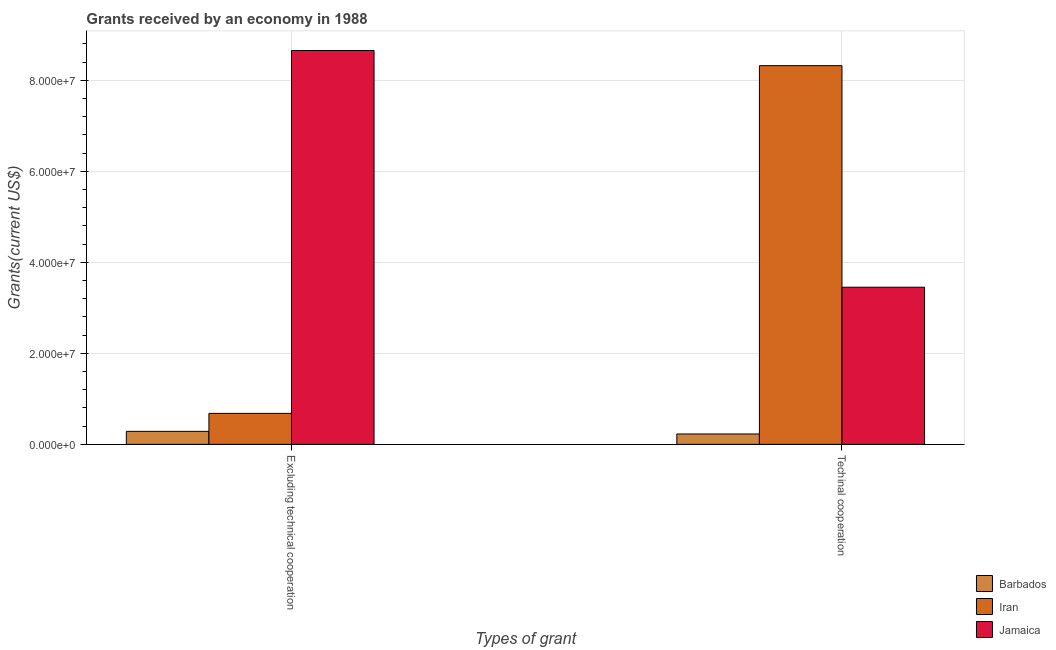How many groups of bars are there?
Give a very brief answer. 2. Are the number of bars per tick equal to the number of legend labels?
Your answer should be compact. Yes. Are the number of bars on each tick of the X-axis equal?
Your answer should be very brief. Yes. How many bars are there on the 2nd tick from the left?
Provide a succinct answer. 3. What is the label of the 1st group of bars from the left?
Ensure brevity in your answer.  Excluding technical cooperation. What is the amount of grants received(including technical cooperation) in Jamaica?
Provide a short and direct response. 3.45e+07. Across all countries, what is the maximum amount of grants received(including technical cooperation)?
Offer a terse response. 8.32e+07. Across all countries, what is the minimum amount of grants received(including technical cooperation)?
Offer a terse response. 2.28e+06. In which country was the amount of grants received(excluding technical cooperation) maximum?
Your answer should be compact. Jamaica. In which country was the amount of grants received(excluding technical cooperation) minimum?
Provide a succinct answer. Barbados. What is the total amount of grants received(excluding technical cooperation) in the graph?
Make the answer very short. 9.62e+07. What is the difference between the amount of grants received(excluding technical cooperation) in Iran and that in Barbados?
Provide a short and direct response. 3.95e+06. What is the difference between the amount of grants received(including technical cooperation) in Jamaica and the amount of grants received(excluding technical cooperation) in Iran?
Offer a very short reply. 2.77e+07. What is the average amount of grants received(excluding technical cooperation) per country?
Your answer should be very brief. 3.21e+07. What is the difference between the amount of grants received(excluding technical cooperation) and amount of grants received(including technical cooperation) in Jamaica?
Offer a terse response. 5.20e+07. In how many countries, is the amount of grants received(excluding technical cooperation) greater than 20000000 US$?
Your answer should be compact. 1. What is the ratio of the amount of grants received(including technical cooperation) in Jamaica to that in Iran?
Ensure brevity in your answer.  0.41. Is the amount of grants received(excluding technical cooperation) in Iran less than that in Barbados?
Your answer should be very brief. No. What does the 3rd bar from the left in Techinal cooperation represents?
Offer a terse response. Jamaica. What does the 1st bar from the right in Techinal cooperation represents?
Offer a very short reply. Jamaica. How many bars are there?
Offer a very short reply. 6. Are all the bars in the graph horizontal?
Your answer should be compact. No. Are the values on the major ticks of Y-axis written in scientific E-notation?
Ensure brevity in your answer.  Yes. How are the legend labels stacked?
Provide a succinct answer. Vertical. What is the title of the graph?
Offer a very short reply. Grants received by an economy in 1988. What is the label or title of the X-axis?
Keep it short and to the point. Types of grant. What is the label or title of the Y-axis?
Provide a short and direct response. Grants(current US$). What is the Grants(current US$) of Barbados in Excluding technical cooperation?
Provide a succinct answer. 2.86e+06. What is the Grants(current US$) in Iran in Excluding technical cooperation?
Your answer should be compact. 6.81e+06. What is the Grants(current US$) in Jamaica in Excluding technical cooperation?
Offer a very short reply. 8.66e+07. What is the Grants(current US$) in Barbados in Techinal cooperation?
Offer a very short reply. 2.28e+06. What is the Grants(current US$) of Iran in Techinal cooperation?
Ensure brevity in your answer.  8.32e+07. What is the Grants(current US$) of Jamaica in Techinal cooperation?
Provide a succinct answer. 3.45e+07. Across all Types of grant, what is the maximum Grants(current US$) in Barbados?
Your answer should be compact. 2.86e+06. Across all Types of grant, what is the maximum Grants(current US$) in Iran?
Give a very brief answer. 8.32e+07. Across all Types of grant, what is the maximum Grants(current US$) in Jamaica?
Your answer should be compact. 8.66e+07. Across all Types of grant, what is the minimum Grants(current US$) in Barbados?
Keep it short and to the point. 2.28e+06. Across all Types of grant, what is the minimum Grants(current US$) of Iran?
Your answer should be very brief. 6.81e+06. Across all Types of grant, what is the minimum Grants(current US$) in Jamaica?
Ensure brevity in your answer.  3.45e+07. What is the total Grants(current US$) of Barbados in the graph?
Offer a very short reply. 5.14e+06. What is the total Grants(current US$) of Iran in the graph?
Provide a short and direct response. 9.00e+07. What is the total Grants(current US$) of Jamaica in the graph?
Your answer should be very brief. 1.21e+08. What is the difference between the Grants(current US$) in Barbados in Excluding technical cooperation and that in Techinal cooperation?
Your response must be concise. 5.80e+05. What is the difference between the Grants(current US$) of Iran in Excluding technical cooperation and that in Techinal cooperation?
Keep it short and to the point. -7.64e+07. What is the difference between the Grants(current US$) of Jamaica in Excluding technical cooperation and that in Techinal cooperation?
Keep it short and to the point. 5.20e+07. What is the difference between the Grants(current US$) in Barbados in Excluding technical cooperation and the Grants(current US$) in Iran in Techinal cooperation?
Make the answer very short. -8.04e+07. What is the difference between the Grants(current US$) in Barbados in Excluding technical cooperation and the Grants(current US$) in Jamaica in Techinal cooperation?
Keep it short and to the point. -3.17e+07. What is the difference between the Grants(current US$) of Iran in Excluding technical cooperation and the Grants(current US$) of Jamaica in Techinal cooperation?
Provide a short and direct response. -2.77e+07. What is the average Grants(current US$) in Barbados per Types of grant?
Give a very brief answer. 2.57e+06. What is the average Grants(current US$) of Iran per Types of grant?
Provide a short and direct response. 4.50e+07. What is the average Grants(current US$) of Jamaica per Types of grant?
Offer a very short reply. 6.06e+07. What is the difference between the Grants(current US$) in Barbados and Grants(current US$) in Iran in Excluding technical cooperation?
Your response must be concise. -3.95e+06. What is the difference between the Grants(current US$) of Barbados and Grants(current US$) of Jamaica in Excluding technical cooperation?
Give a very brief answer. -8.37e+07. What is the difference between the Grants(current US$) in Iran and Grants(current US$) in Jamaica in Excluding technical cooperation?
Make the answer very short. -7.98e+07. What is the difference between the Grants(current US$) in Barbados and Grants(current US$) in Iran in Techinal cooperation?
Your answer should be very brief. -8.10e+07. What is the difference between the Grants(current US$) of Barbados and Grants(current US$) of Jamaica in Techinal cooperation?
Your response must be concise. -3.23e+07. What is the difference between the Grants(current US$) in Iran and Grants(current US$) in Jamaica in Techinal cooperation?
Give a very brief answer. 4.87e+07. What is the ratio of the Grants(current US$) in Barbados in Excluding technical cooperation to that in Techinal cooperation?
Give a very brief answer. 1.25. What is the ratio of the Grants(current US$) of Iran in Excluding technical cooperation to that in Techinal cooperation?
Keep it short and to the point. 0.08. What is the ratio of the Grants(current US$) in Jamaica in Excluding technical cooperation to that in Techinal cooperation?
Your answer should be very brief. 2.51. What is the difference between the highest and the second highest Grants(current US$) of Barbados?
Give a very brief answer. 5.80e+05. What is the difference between the highest and the second highest Grants(current US$) in Iran?
Offer a very short reply. 7.64e+07. What is the difference between the highest and the second highest Grants(current US$) of Jamaica?
Give a very brief answer. 5.20e+07. What is the difference between the highest and the lowest Grants(current US$) in Barbados?
Offer a terse response. 5.80e+05. What is the difference between the highest and the lowest Grants(current US$) of Iran?
Ensure brevity in your answer.  7.64e+07. What is the difference between the highest and the lowest Grants(current US$) of Jamaica?
Provide a short and direct response. 5.20e+07. 